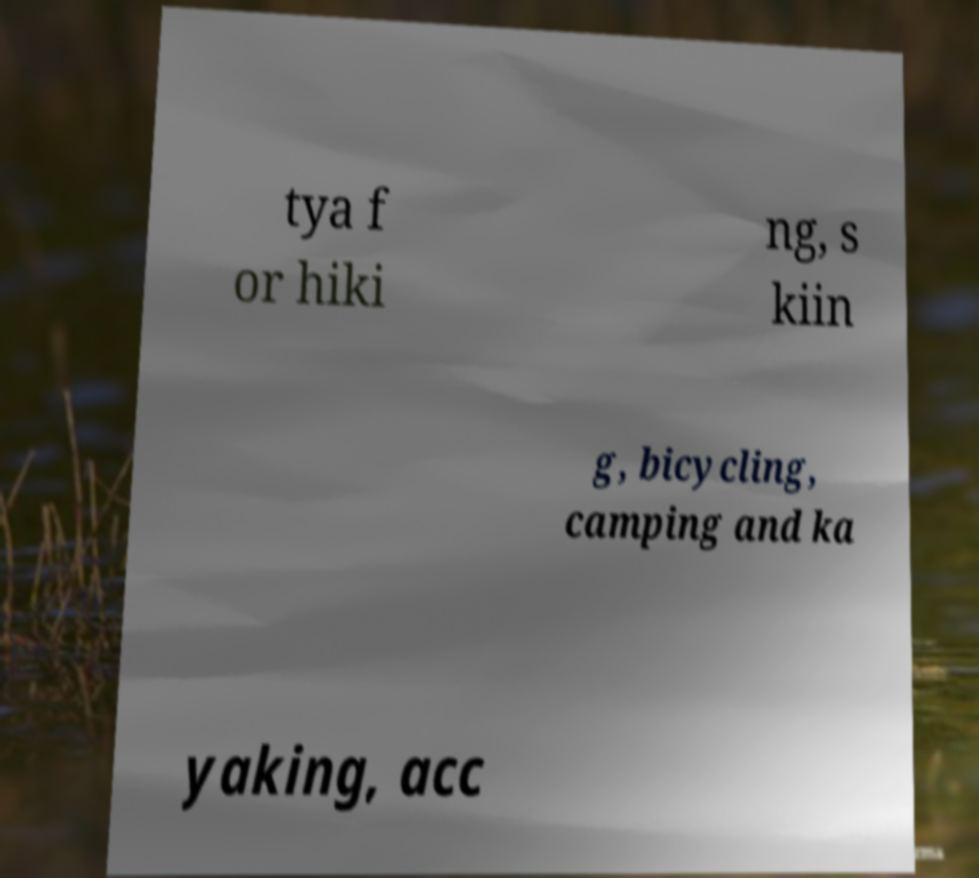Please read and relay the text visible in this image. What does it say? tya f or hiki ng, s kiin g, bicycling, camping and ka yaking, acc 